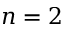Convert formula to latex. <formula><loc_0><loc_0><loc_500><loc_500>n = 2</formula> 